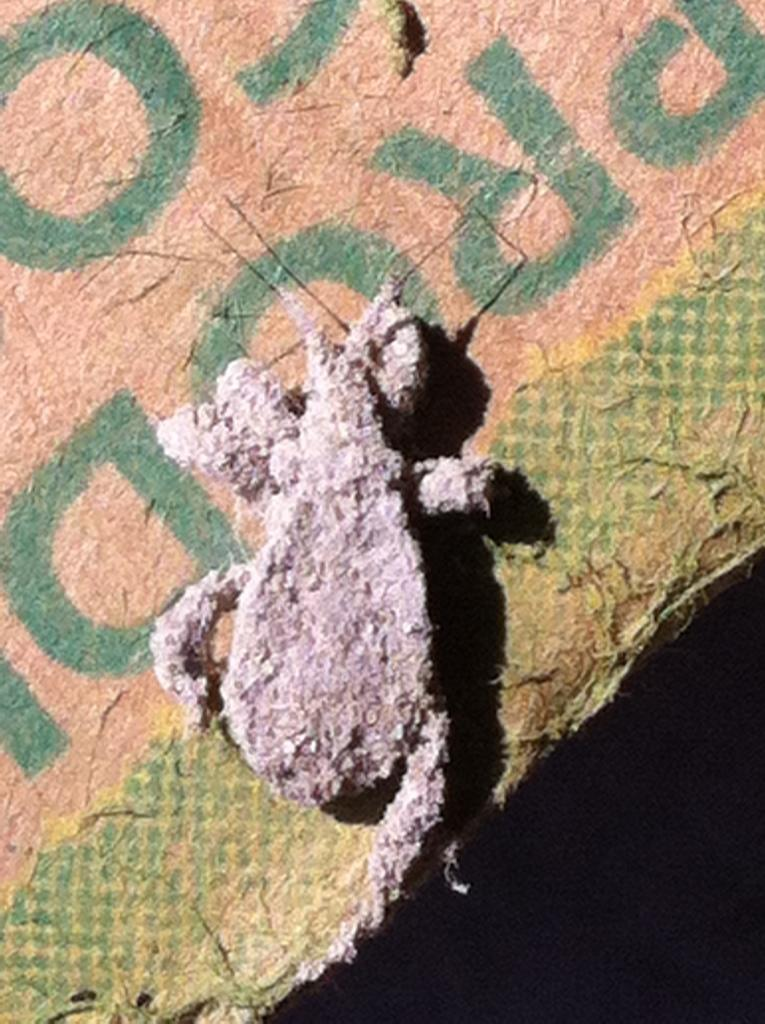What is the main object in the image? There is a toy in the image. Where is the toy placed? The toy is on a cardboard sheet. What type of wilderness can be seen in the background of the image? There is no wilderness visible in the image; it only shows a toy on a cardboard sheet. 